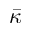Convert formula to latex. <formula><loc_0><loc_0><loc_500><loc_500>\bar { \kappa }</formula> 